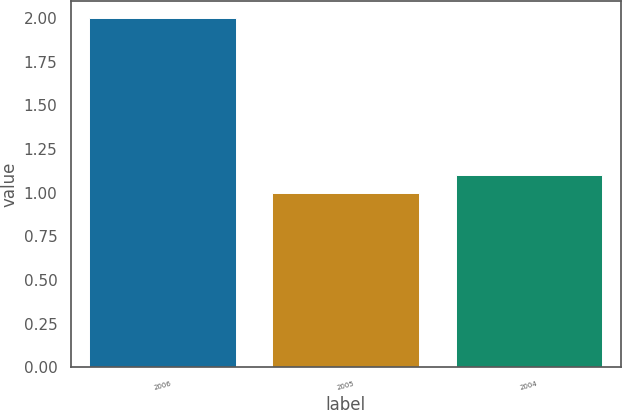Convert chart. <chart><loc_0><loc_0><loc_500><loc_500><bar_chart><fcel>2006<fcel>2005<fcel>2004<nl><fcel>2<fcel>1<fcel>1.1<nl></chart> 